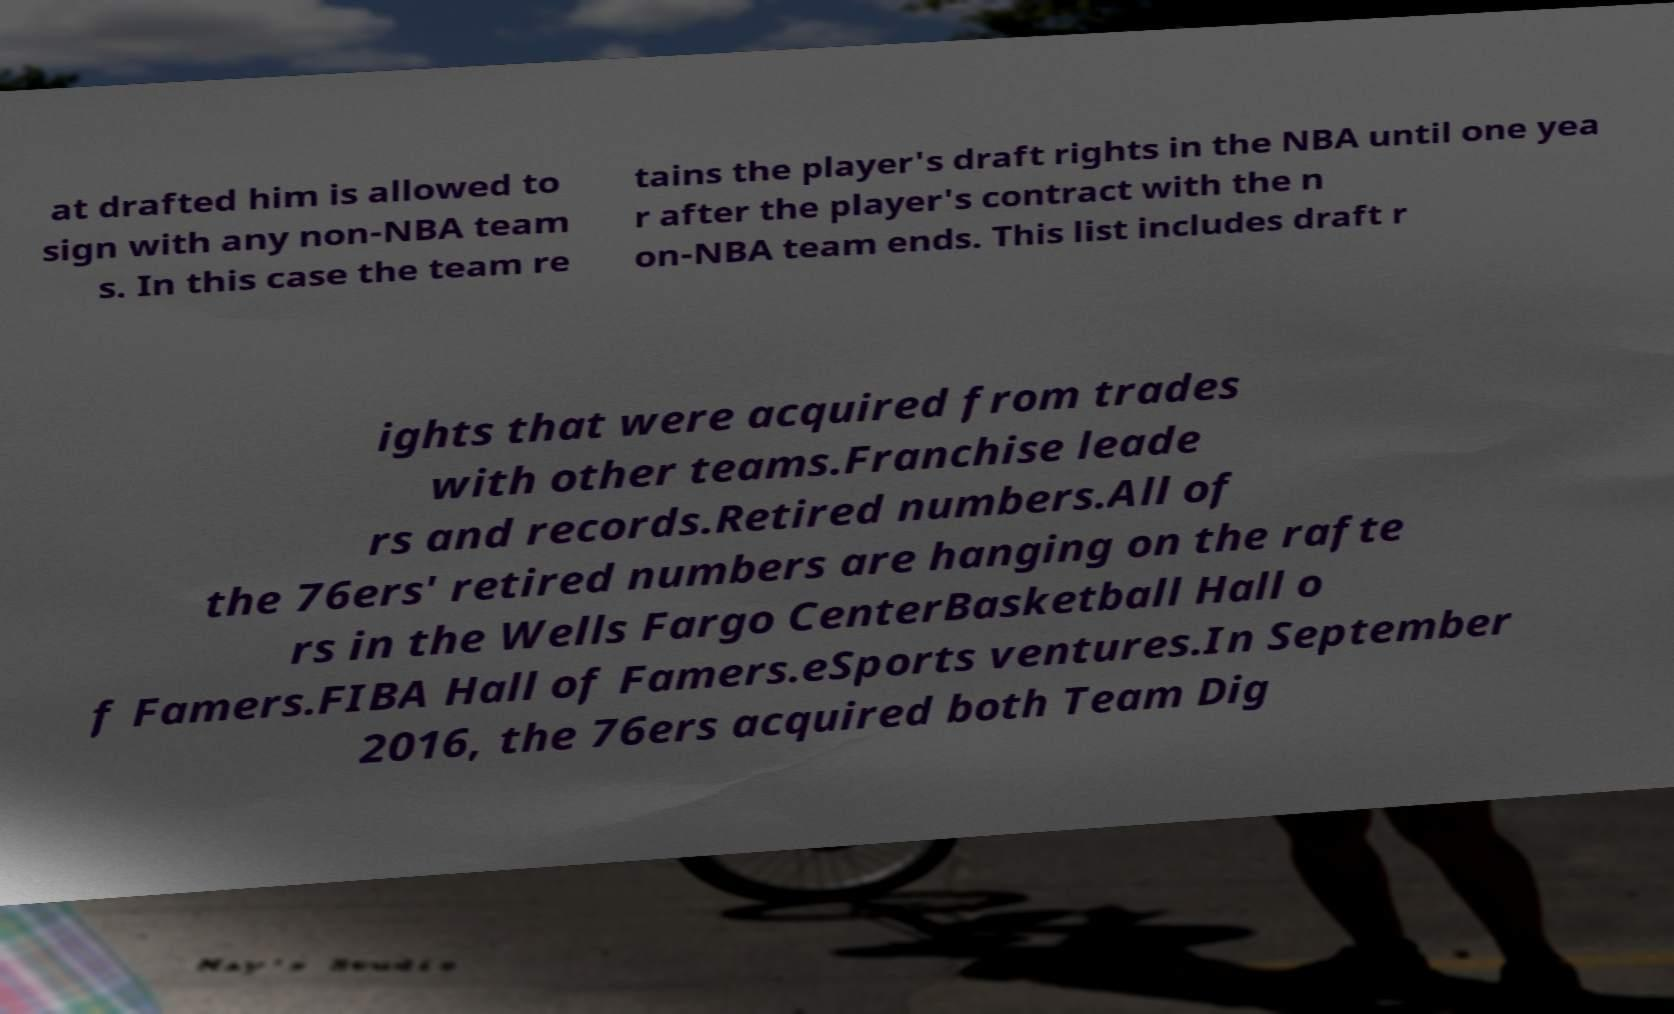I need the written content from this picture converted into text. Can you do that? at drafted him is allowed to sign with any non-NBA team s. In this case the team re tains the player's draft rights in the NBA until one yea r after the player's contract with the n on-NBA team ends. This list includes draft r ights that were acquired from trades with other teams.Franchise leade rs and records.Retired numbers.All of the 76ers' retired numbers are hanging on the rafte rs in the Wells Fargo CenterBasketball Hall o f Famers.FIBA Hall of Famers.eSports ventures.In September 2016, the 76ers acquired both Team Dig 